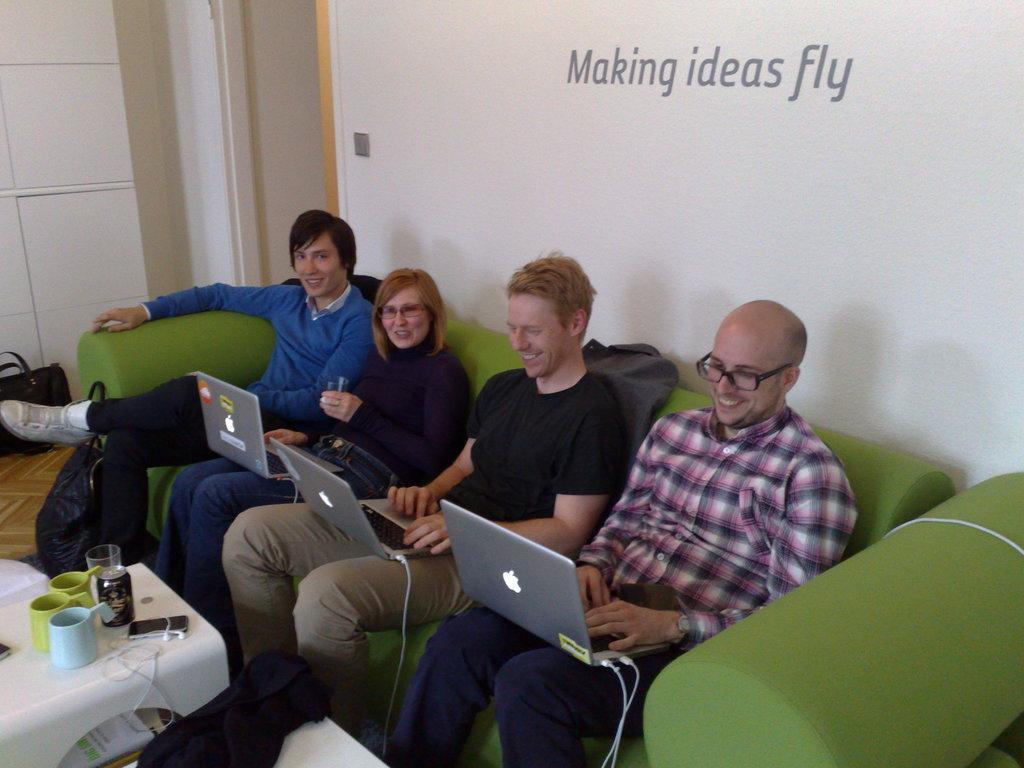Please provide a concise description of this image. In this picture we can see four peoples they are sitting on the sofa and three peoples are working with their laptops in front of them we can see cups and some accessories like mobile and earphones. 